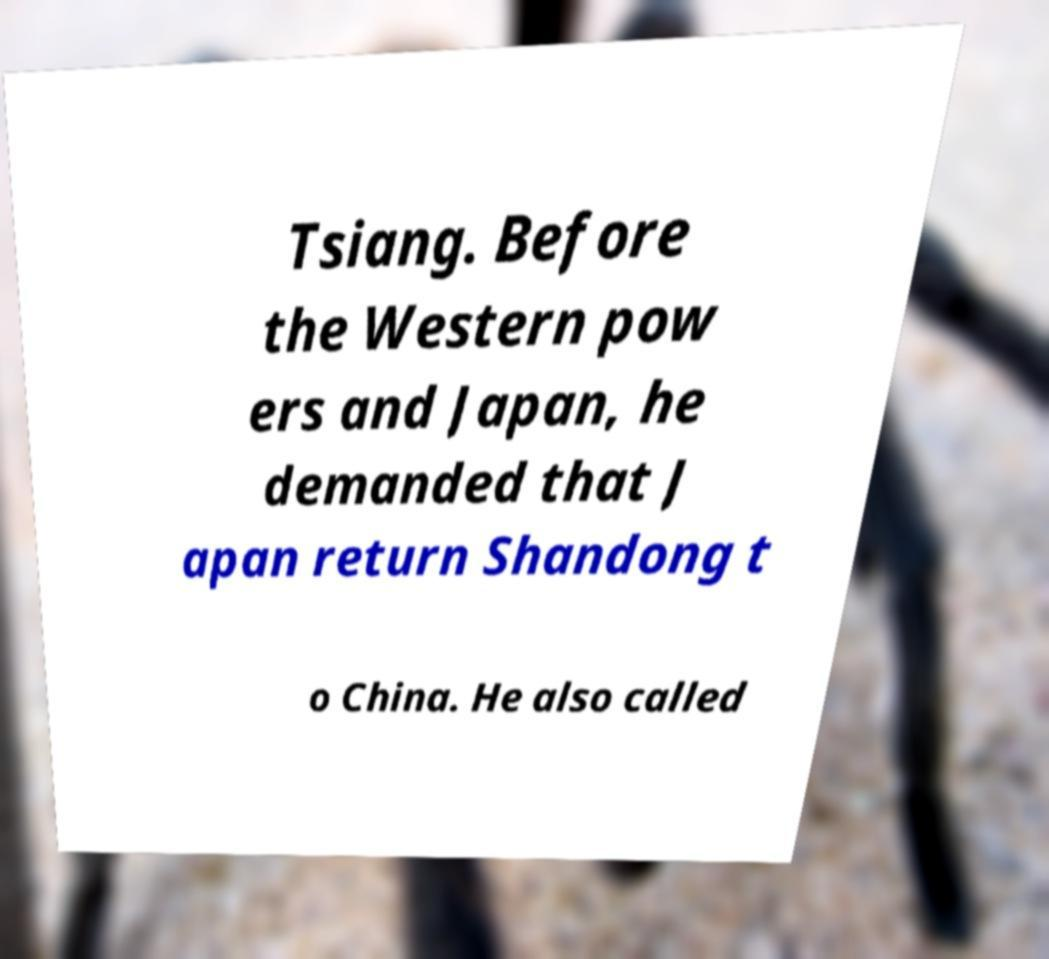Please read and relay the text visible in this image. What does it say? Tsiang. Before the Western pow ers and Japan, he demanded that J apan return Shandong t o China. He also called 